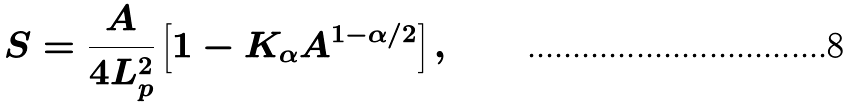<formula> <loc_0><loc_0><loc_500><loc_500>S = \frac { A } { 4 L _ { p } ^ { 2 } } \left [ 1 - K _ { \alpha } A ^ { 1 - \alpha / 2 } \right ] ,</formula> 